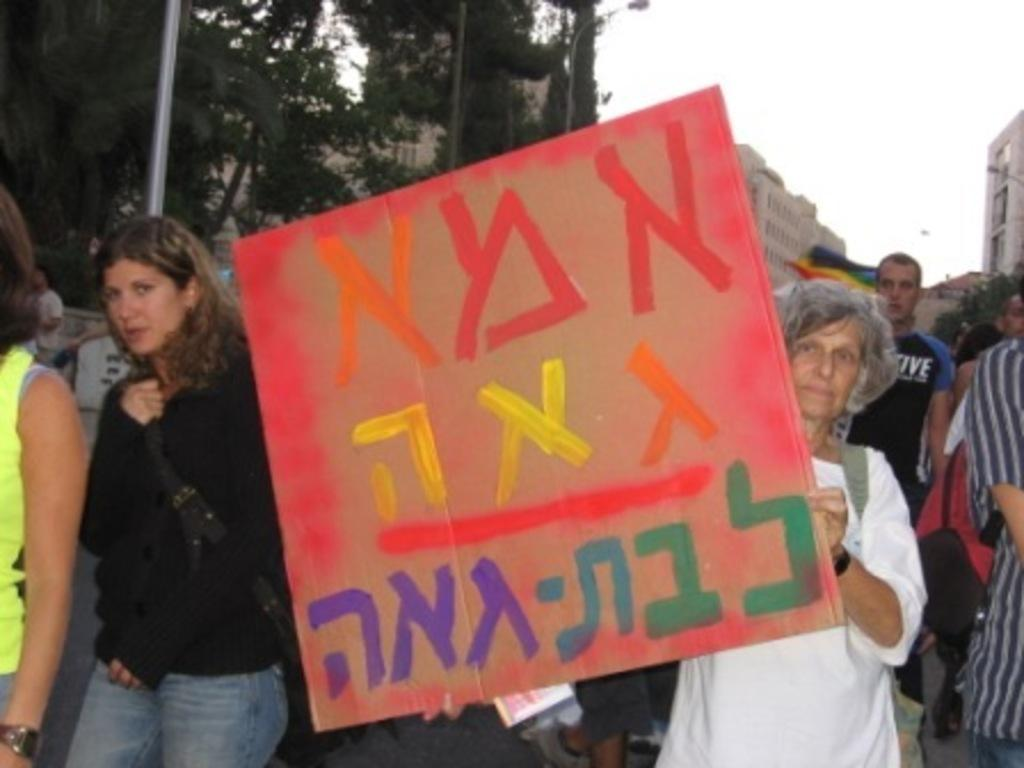Who is present in the image? There is a woman in the image. What is the woman holding? The woman is holding a board. What can be seen in the background of the image? There are buildings, light poles, trees, a flag, and people in the background of the image. How many chairs are visible in the image? There are no chairs visible in the image. What type of eggs can be seen in the image? There are no eggs present in the image. 